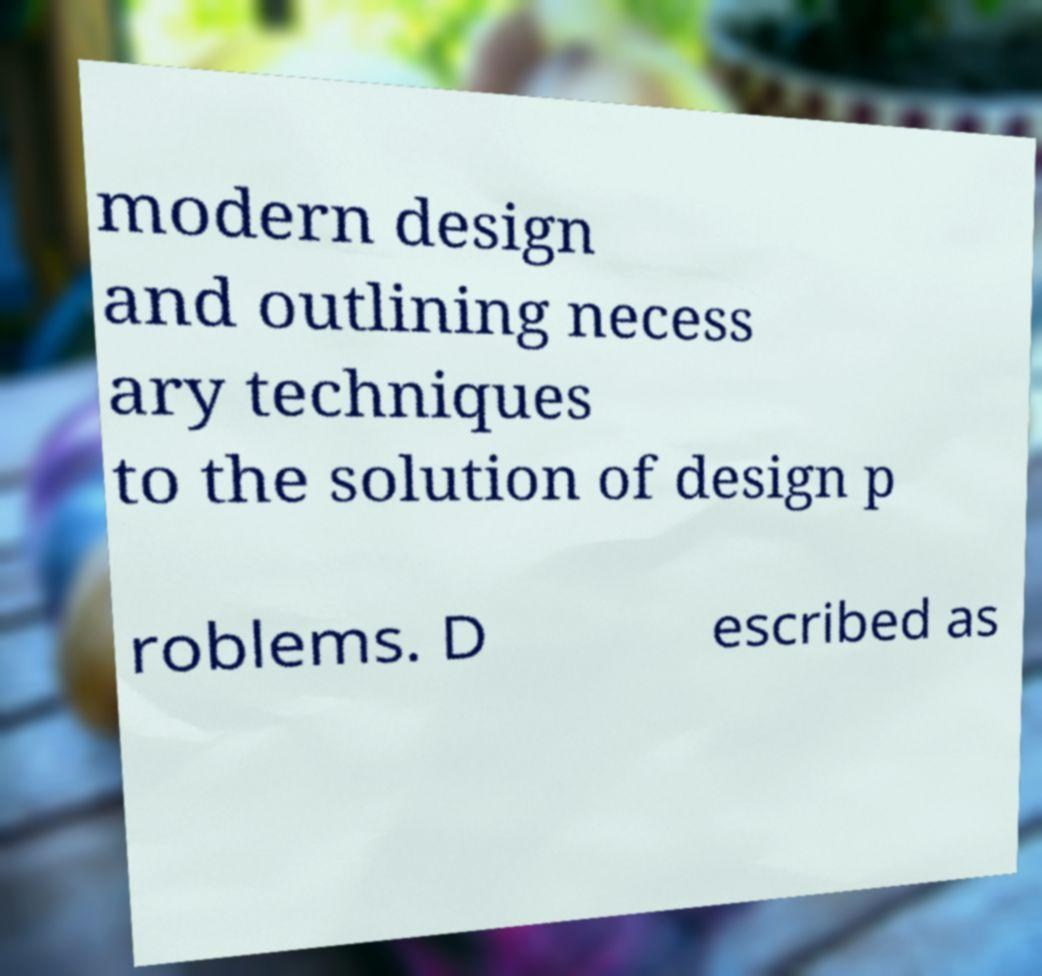Could you extract and type out the text from this image? modern design and outlining necess ary techniques to the solution of design p roblems. D escribed as 